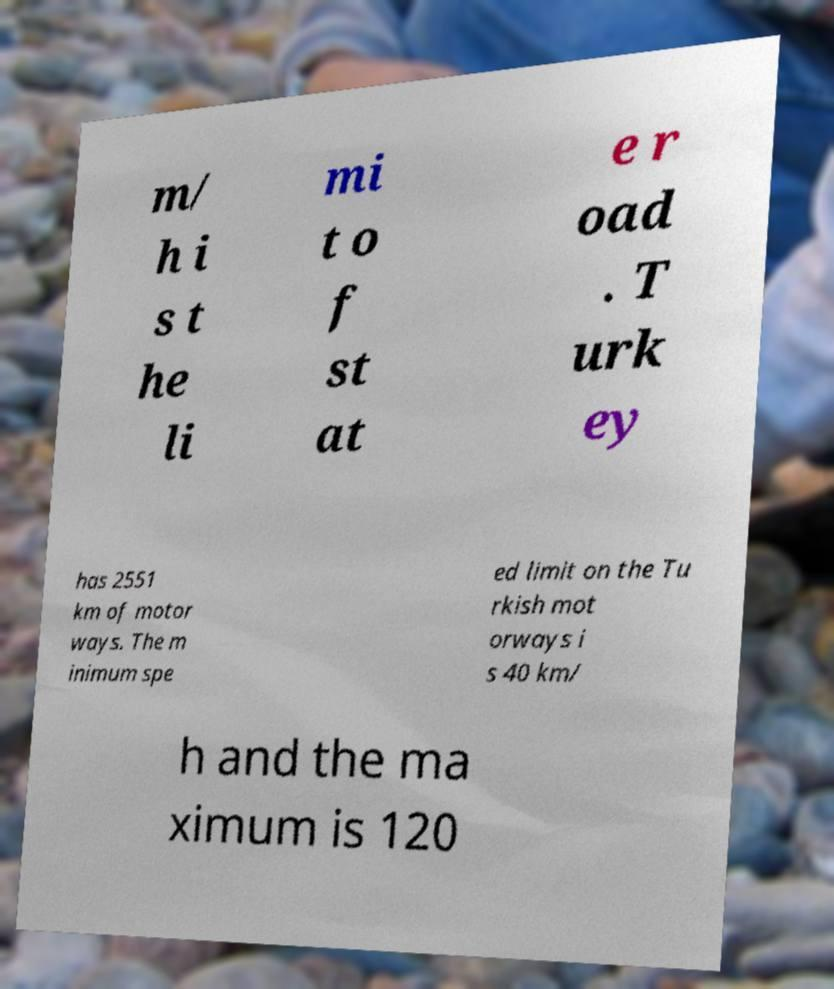Could you extract and type out the text from this image? m/ h i s t he li mi t o f st at e r oad . T urk ey has 2551 km of motor ways. The m inimum spe ed limit on the Tu rkish mot orways i s 40 km/ h and the ma ximum is 120 